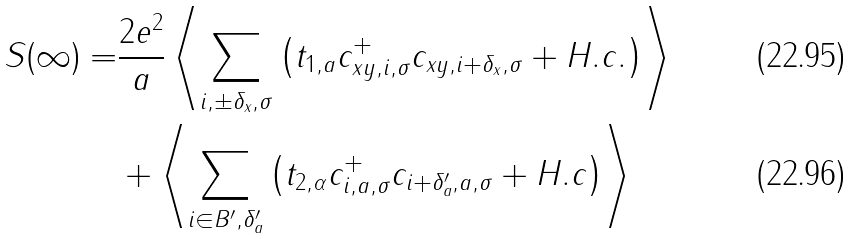Convert formula to latex. <formula><loc_0><loc_0><loc_500><loc_500>S ( \infty ) = & \frac { 2 e ^ { 2 } } { a } \left \langle \sum _ { i , \pm \delta _ { x } , \sigma } \left ( t _ { 1 , a } c _ { x y , i , \sigma } ^ { + } c _ { x y , i + \delta _ { x } , \sigma } + H . c . \right ) \right \rangle \\ & + \left \langle \sum _ { i \in B ^ { \prime } , \delta _ { a } ^ { \prime } } \left ( t _ { 2 , \alpha } c _ { i , a , \sigma } ^ { + } c _ { i + \delta _ { a } ^ { \prime } , a , \sigma } + H . c \right ) \right \rangle</formula> 